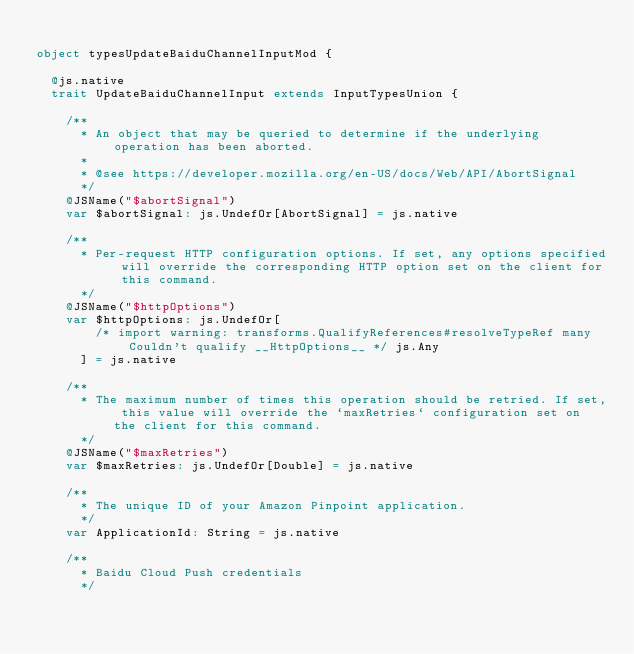<code> <loc_0><loc_0><loc_500><loc_500><_Scala_>
object typesUpdateBaiduChannelInputMod {
  
  @js.native
  trait UpdateBaiduChannelInput extends InputTypesUnion {
    
    /**
      * An object that may be queried to determine if the underlying operation has been aborted.
      *
      * @see https://developer.mozilla.org/en-US/docs/Web/API/AbortSignal
      */
    @JSName("$abortSignal")
    var $abortSignal: js.UndefOr[AbortSignal] = js.native
    
    /**
      * Per-request HTTP configuration options. If set, any options specified will override the corresponding HTTP option set on the client for this command.
      */
    @JSName("$httpOptions")
    var $httpOptions: js.UndefOr[
        /* import warning: transforms.QualifyReferences#resolveTypeRef many Couldn't qualify __HttpOptions__ */ js.Any
      ] = js.native
    
    /**
      * The maximum number of times this operation should be retried. If set, this value will override the `maxRetries` configuration set on the client for this command.
      */
    @JSName("$maxRetries")
    var $maxRetries: js.UndefOr[Double] = js.native
    
    /**
      * The unique ID of your Amazon Pinpoint application.
      */
    var ApplicationId: String = js.native
    
    /**
      * Baidu Cloud Push credentials
      */</code> 